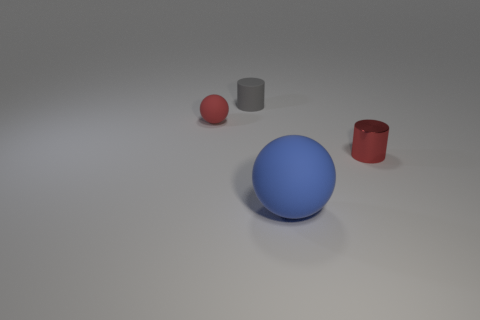Add 1 small red things. How many objects exist? 5 Add 2 gray objects. How many gray objects are left? 3 Add 1 small blue metal blocks. How many small blue metal blocks exist? 1 Subtract 1 red cylinders. How many objects are left? 3 Subtract all blue rubber balls. Subtract all large rubber things. How many objects are left? 2 